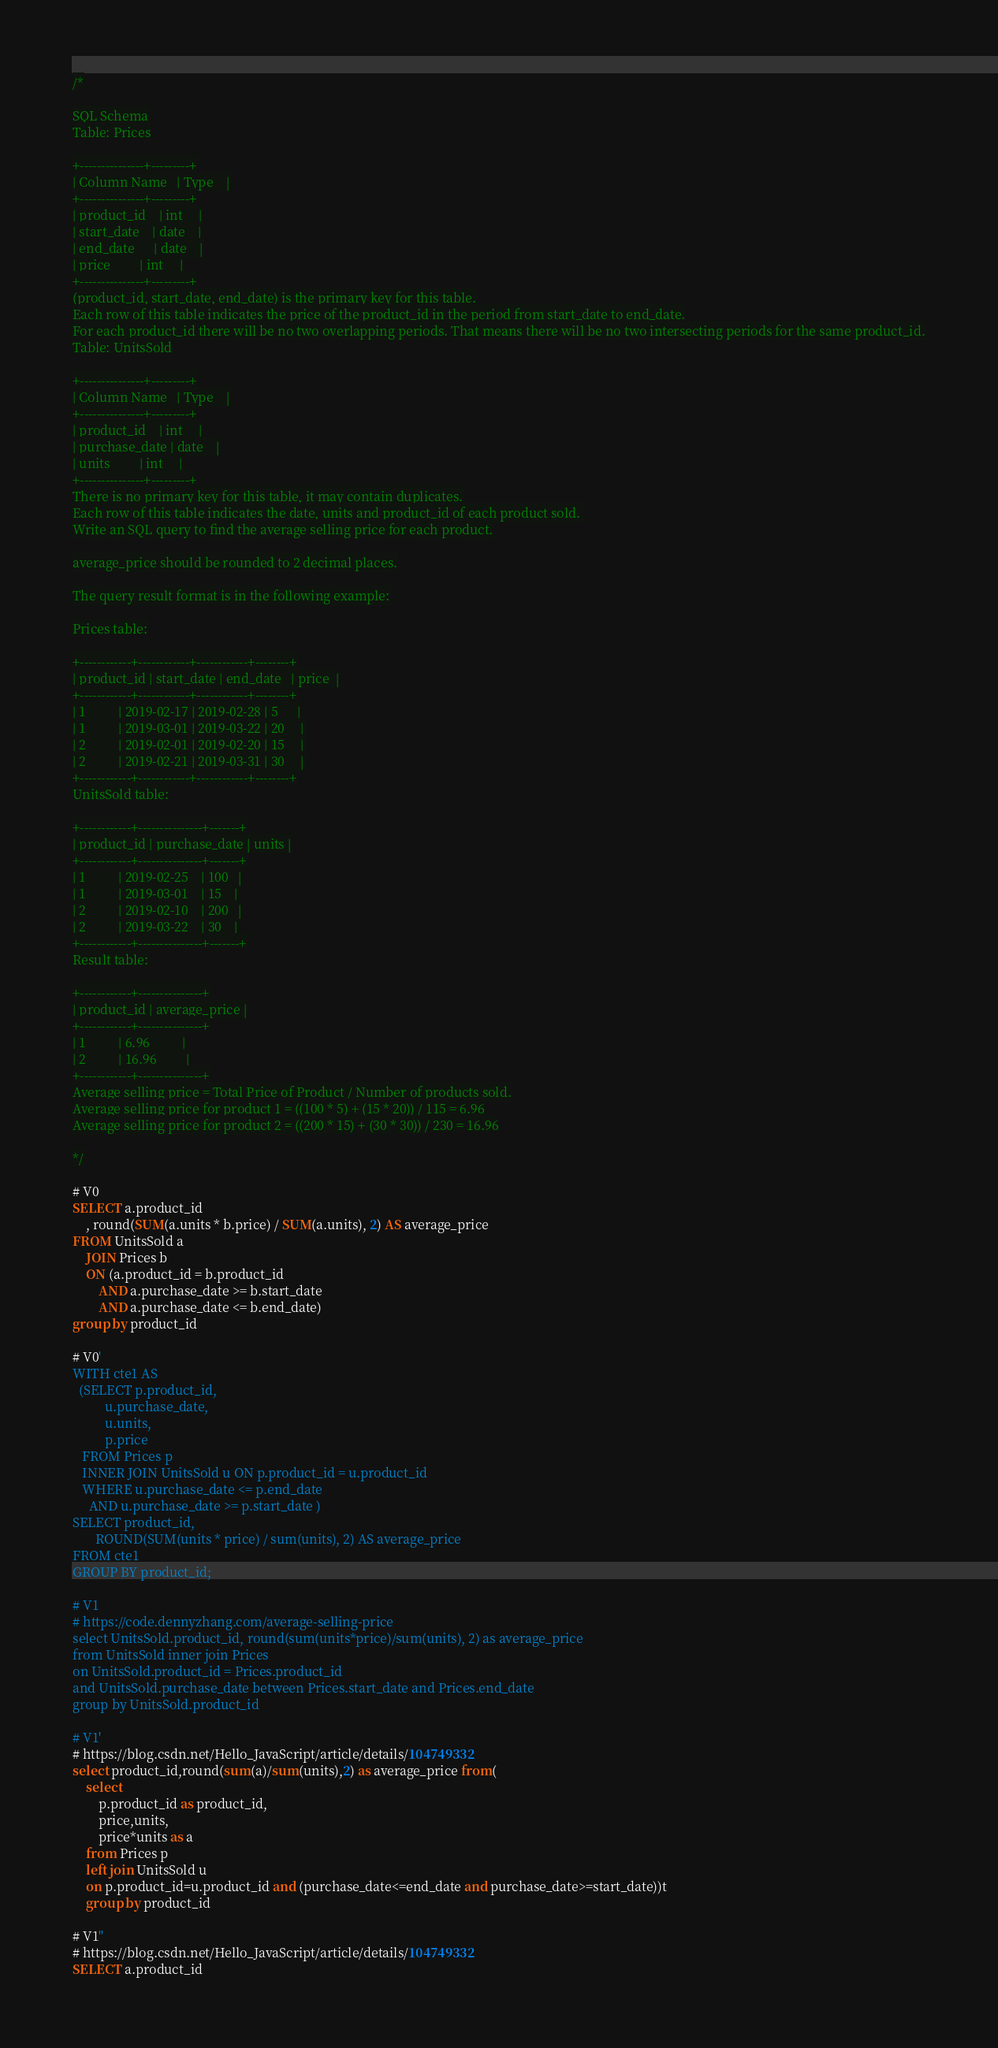<code> <loc_0><loc_0><loc_500><loc_500><_SQL_>/*

SQL Schema
Table: Prices

+---------------+---------+
| Column Name   | Type    |
+---------------+---------+
| product_id    | int     |
| start_date    | date    |
| end_date      | date    |
| price         | int     |
+---------------+---------+
(product_id, start_date, end_date) is the primary key for this table.
Each row of this table indicates the price of the product_id in the period from start_date to end_date.
For each product_id there will be no two overlapping periods. That means there will be no two intersecting periods for the same product_id.
Table: UnitsSold

+---------------+---------+
| Column Name   | Type    |
+---------------+---------+
| product_id    | int     |
| purchase_date | date    |
| units         | int     |
+---------------+---------+
There is no primary key for this table, it may contain duplicates.
Each row of this table indicates the date, units and product_id of each product sold. 
Write an SQL query to find the average selling price for each product.

average_price should be rounded to 2 decimal places.

The query result format is in the following example:

Prices table:

+------------+------------+------------+--------+
| product_id | start_date | end_date   | price  |
+------------+------------+------------+--------+
| 1          | 2019-02-17 | 2019-02-28 | 5      |
| 1          | 2019-03-01 | 2019-03-22 | 20     |
| 2          | 2019-02-01 | 2019-02-20 | 15     |
| 2          | 2019-02-21 | 2019-03-31 | 30     |
+------------+------------+------------+--------+
UnitsSold table:

+------------+---------------+-------+
| product_id | purchase_date | units |
+------------+---------------+-------+
| 1          | 2019-02-25    | 100   |
| 1          | 2019-03-01    | 15    |
| 2          | 2019-02-10    | 200   |
| 2          | 2019-03-22    | 30    |
+------------+---------------+-------+
Result table:

+------------+---------------+
| product_id | average_price |
+------------+---------------+
| 1          | 6.96          |
| 2          | 16.96         |
+------------+---------------+
Average selling price = Total Price of Product / Number of products sold.
Average selling price for product 1 = ((100 * 5) + (15 * 20)) / 115 = 6.96
Average selling price for product 2 = ((200 * 15) + (30 * 30)) / 230 = 16.96

*/

# V0
SELECT a.product_id
	, round(SUM(a.units * b.price) / SUM(a.units), 2) AS average_price
FROM UnitsSold a
	JOIN Prices b
	ON (a.product_id = b.product_id
		AND a.purchase_date >= b.start_date
		AND a.purchase_date <= b.end_date)
group by product_id

# V0'
WITH cte1 AS
  (SELECT p.product_id,
          u.purchase_date,
          u.units,
          p.price
   FROM Prices p
   INNER JOIN UnitsSold u ON p.product_id = u.product_id
   WHERE u.purchase_date <= p.end_date
     AND u.purchase_date >= p.start_date )
SELECT product_id,
       ROUND(SUM(units * price) / sum(units), 2) AS average_price
FROM cte1
GROUP BY product_id;

# V1
# https://code.dennyzhang.com/average-selling-price
select UnitsSold.product_id, round(sum(units*price)/sum(units), 2) as average_price
from UnitsSold inner join Prices
on UnitsSold.product_id = Prices.product_id
and UnitsSold.purchase_date between Prices.start_date and Prices.end_date
group by UnitsSold.product_id

# V1'
# https://blog.csdn.net/Hello_JavaScript/article/details/104749332
select product_id,round(sum(a)/sum(units),2) as average_price from(
    select 
        p.product_id as product_id,
        price,units,
        price*units as a
    from Prices p 
    left join UnitsSold u
    on p.product_id=u.product_id and (purchase_date<=end_date and purchase_date>=start_date))t
    group by product_id

# V1''
# https://blog.csdn.net/Hello_JavaScript/article/details/104749332
SELECT a.product_id</code> 